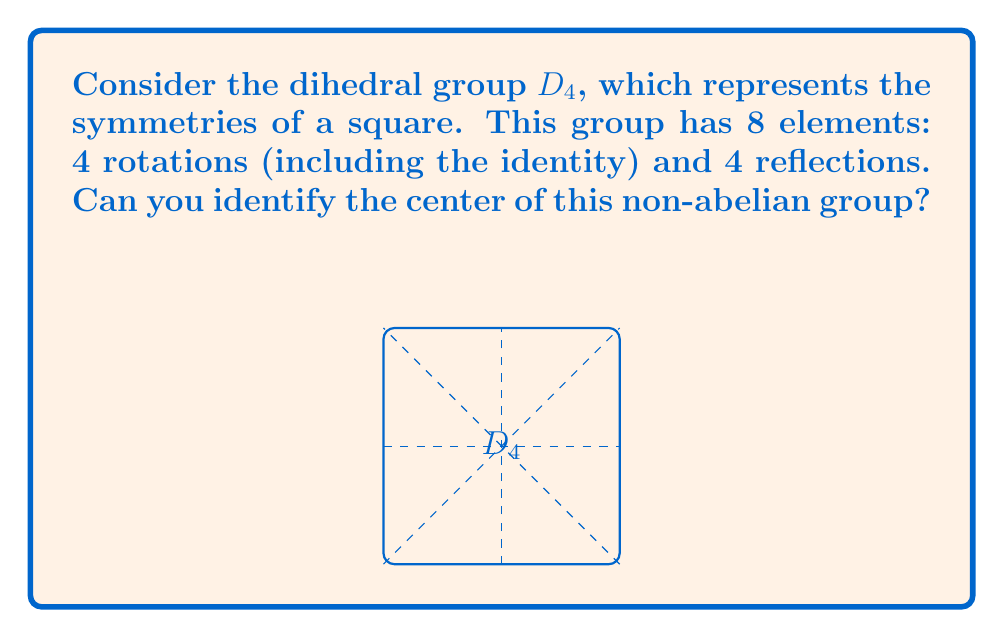Show me your answer to this math problem. Let's approach this step-by-step:

1) Recall that the center of a group $G$ is defined as:
   $$Z(G) = \{z \in G : zg = gz \text{ for all } g \in G\}$$

2) In $D_4$, we have the following elements:
   - Identity: $e$
   - Rotations: $r$ (90°), $r^2$ (180°), $r^3$ (270°)
   - Reflections: $s$ (vertical), $sr$ (diagonal), $sr^2$ (horizontal), $sr^3$ (other diagonal)

3) The identity $e$ always commutes with all elements, so it's always in the center.

4) Let's check the 180° rotation $r^2$:
   - It commutes with all rotations (as rotations are cyclic).
   - For reflections: $r^2s = sr^2$, $r^2(sr) = (sr)r^2$, etc.
   So $r^2$ also commutes with all elements.

5) No other rotation commutes with all reflections, and no reflection commutes with all rotations.

6) Therefore, the center of $D_4$ consists of just $\{e, r^2\}$.

This demonstrates why $D_4$ is non-abelian, as not all elements commute with each other, but it still has a non-trivial center.
Answer: $\{e, r^2\}$ 